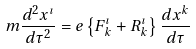Convert formula to latex. <formula><loc_0><loc_0><loc_500><loc_500>m \frac { d ^ { 2 } x ^ { \imath } } { d \tau ^ { 2 } } = e \left \{ F ^ { \imath } _ { k } + R ^ { \imath } _ { k } \right \} \frac { d x ^ { k } } { d \tau }</formula> 